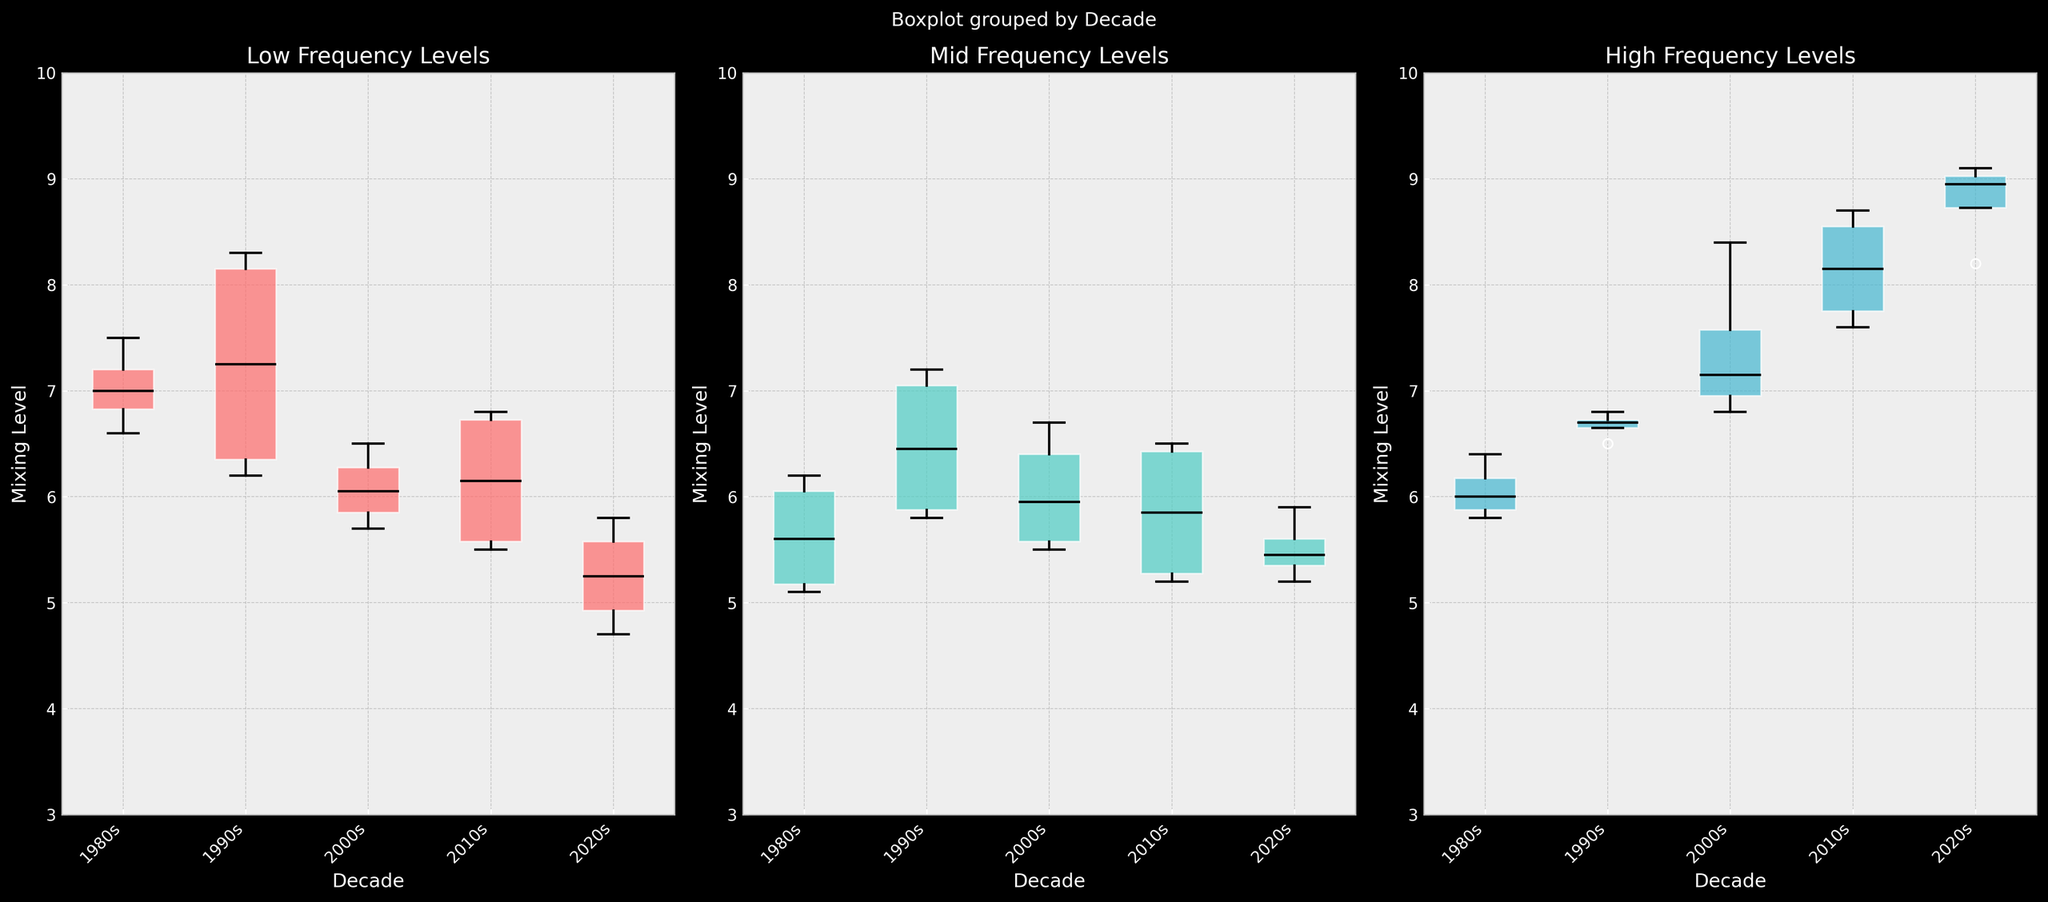How many box plots are there in the figure? The figure has three columns of box plots, each representing one frequency band (Low, Mid, High)
Answer: 3 What is the range of the mixing levels shown on the y-axis? The y-axis range for each subplot is from 3 to 10
Answer: 3 to 10 Which decade shows the highest median mixing level for high frequencies? By looking at the high-frequency subplot, the box plot for the 2020s shows the highest median level
Answer: 2020s Which frequency band demonstrates the most variability in the 2000s? We need to compare the interquartile ranges (IQR) of the 2000s box plots across all three frequency bands. The High_Frequency has the widest IQR, indicating the most variability
Answer: High Frequency In the 1990s, are the low frequencies generally mixed higher or lower than mid frequencies? Compare the medians in the low and mid frequency subplots for the 1990s. The median value for low frequencies is higher than that of mid frequencies
Answer: Higher Is the median mixing level for low frequencies higher in the 1990s or the 2010s? Compare the median levels in the low frequency subplot for the 1990s and 2010s. The 1990s has a higher median compared to the 2010s
Answer: 1990s Which decade shows the least variability in mid frequencies based on the interquartile range? By analyzing the width of the boxes in the mid frequency subplot, the 2010s show the least variability (smallest IQR)
Answer: 2010s Are the medians of high frequencies in the 1980s and 2000s closer or farther apart than those in low frequencies for the same decades? By comparing the distances between the medians for high frequencies and the medians for low frequencies in these two decades, the high frequencies medians are farther apart than the low frequencies medians
Answer: Farther apart In which frequency band do all decades show increasing trends in their median values? By comparing the median values across decades for each frequency band, mid and high frequencies show increasing trends, but high frequencies are consistently increasing
Answer: High Frequency 